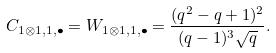Convert formula to latex. <formula><loc_0><loc_0><loc_500><loc_500>C _ { 1 \otimes 1 , 1 , \bullet } = W _ { 1 \otimes 1 , 1 , \bullet } = \frac { ( q ^ { 2 } - q + 1 ) ^ { 2 } } { ( q - 1 ) ^ { 3 } \sqrt { q } } .</formula> 